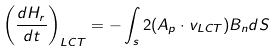Convert formula to latex. <formula><loc_0><loc_0><loc_500><loc_500>\left ( \frac { d H _ { r } } { d t } \right ) _ { L C T } = - \int _ { s } 2 ( { A } _ { p } \cdot { v } _ { L C T } ) B _ { n } d S</formula> 